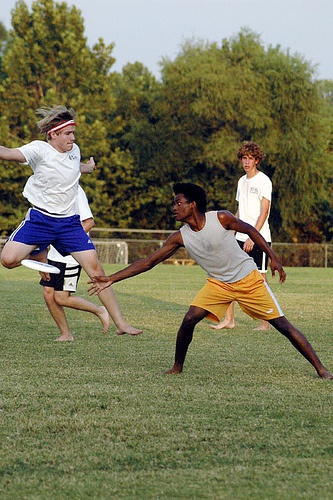Describe the objects in this image and their specific colors. I can see people in lightgray, black, darkgray, maroon, and orange tones, people in lightgray, darkgray, darkblue, and tan tones, people in lightgray, white, black, and tan tones, people in lightgray, white, black, gray, and tan tones, and frisbee in lightgray, white, darkgray, and black tones in this image. 